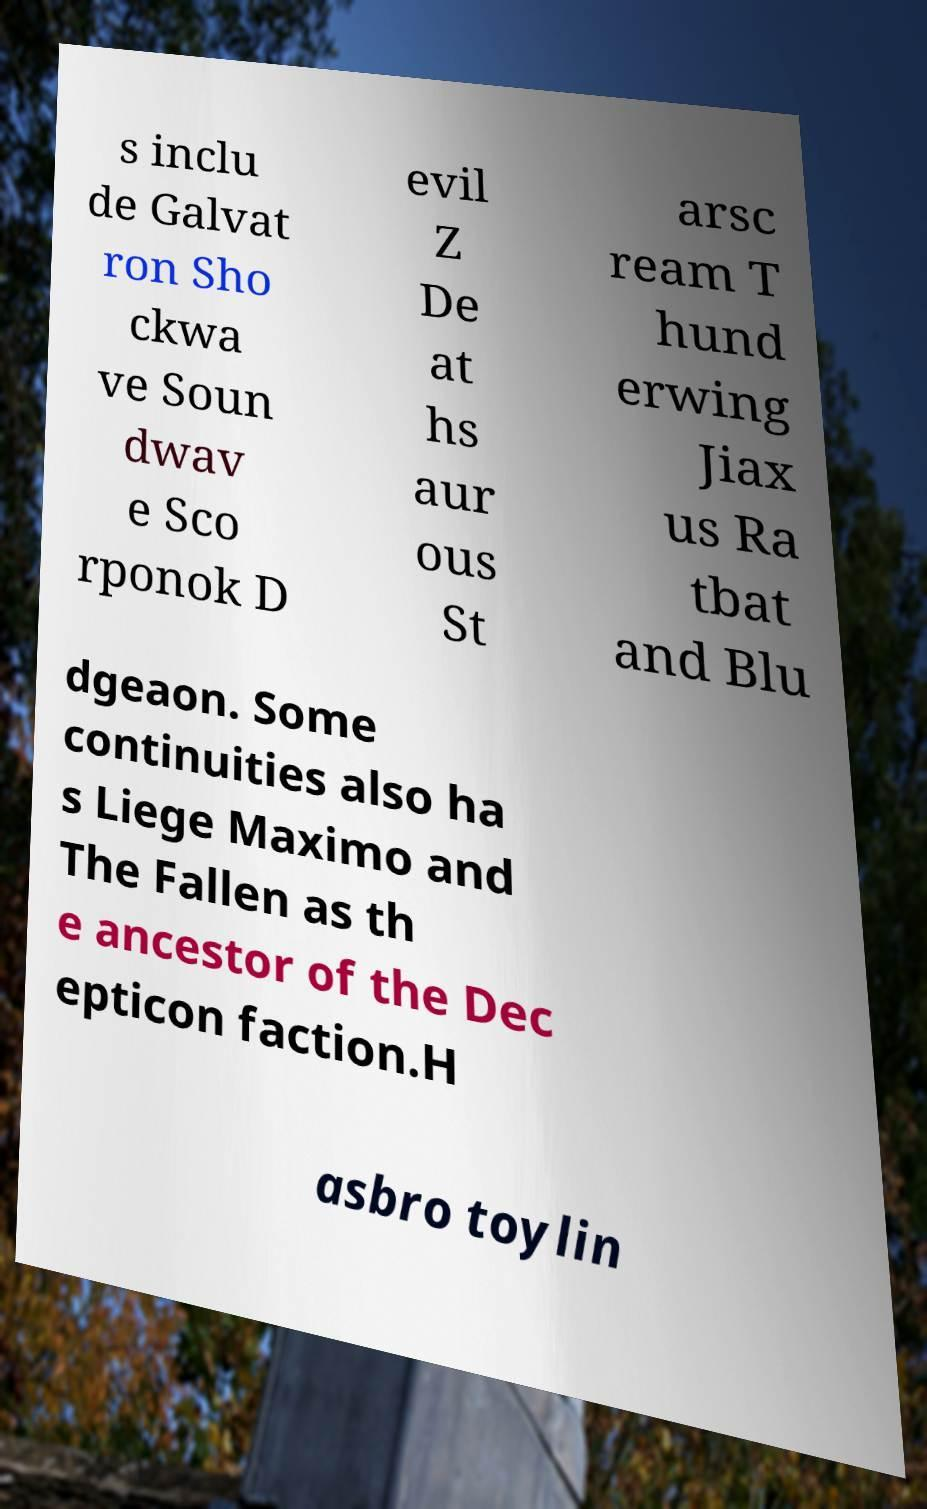Can you read and provide the text displayed in the image?This photo seems to have some interesting text. Can you extract and type it out for me? s inclu de Galvat ron Sho ckwa ve Soun dwav e Sco rponok D evil Z De at hs aur ous St arsc ream T hund erwing Jiax us Ra tbat and Blu dgeaon. Some continuities also ha s Liege Maximo and The Fallen as th e ancestor of the Dec epticon faction.H asbro toylin 